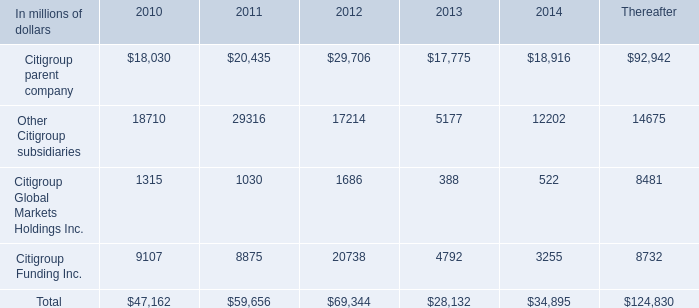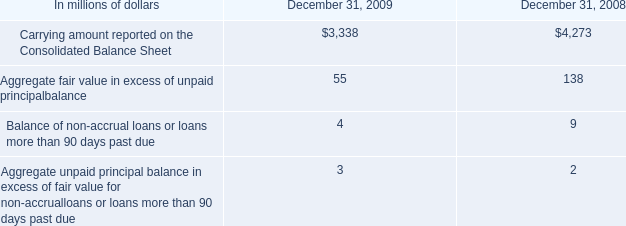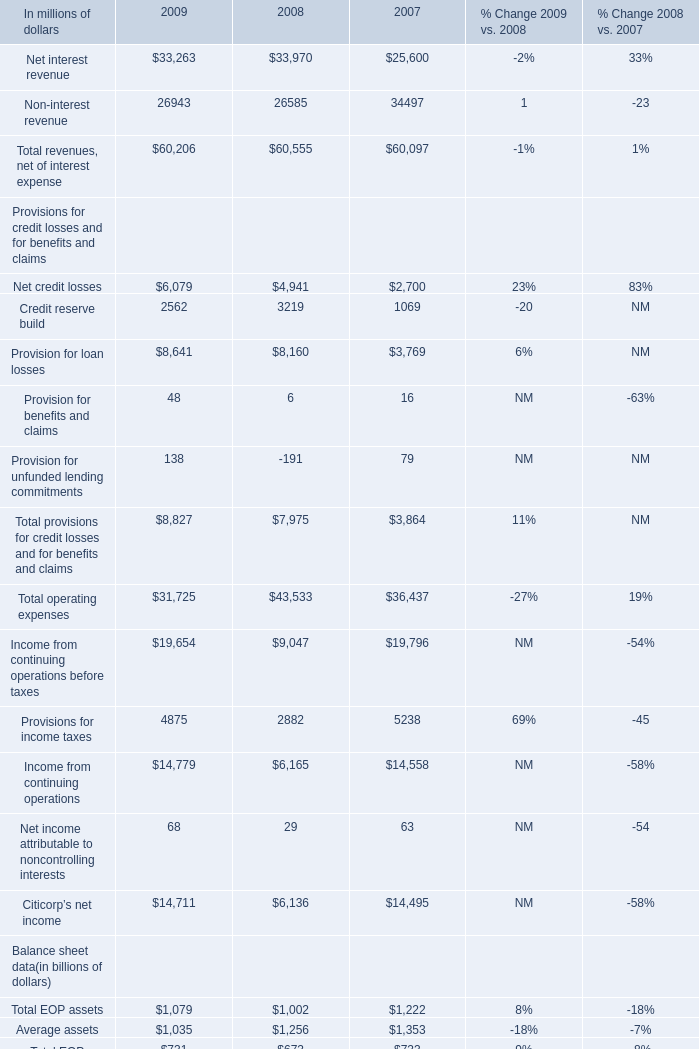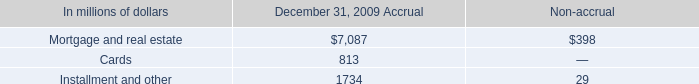What's the average of Citigroup parent company of 2013, and Installment and other of December 31, 2009 Accrual ? 
Computations: ((17775.0 + 1734.0) / 2)
Answer: 9754.5. 